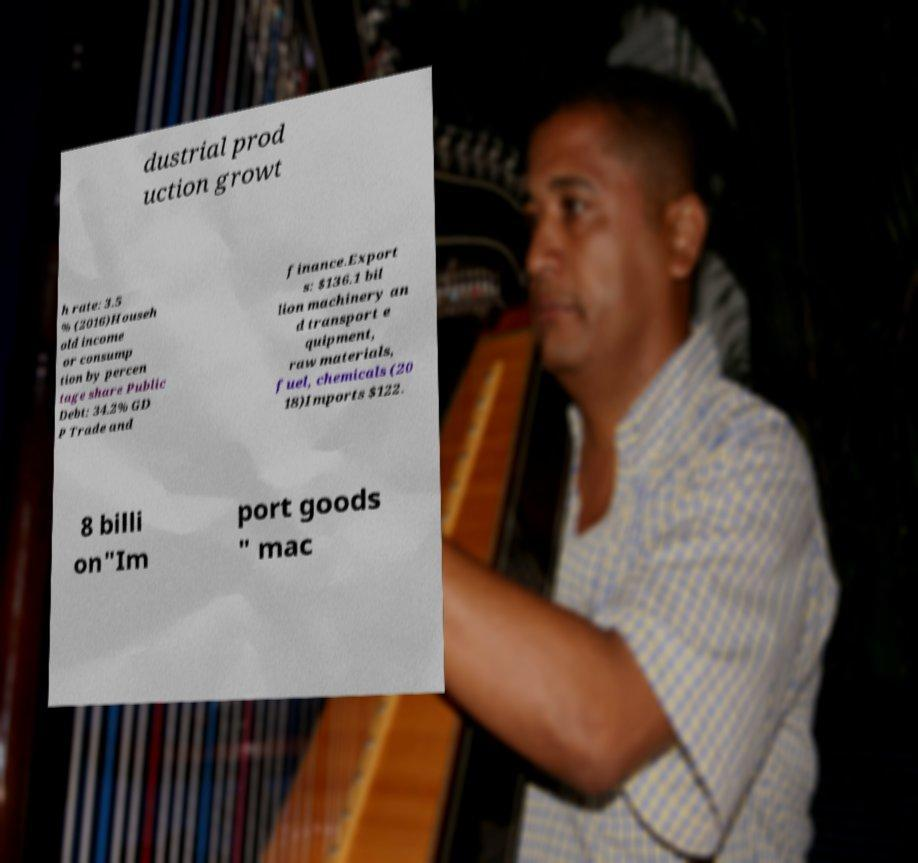I need the written content from this picture converted into text. Can you do that? dustrial prod uction growt h rate: 3.5 % (2016)Househ old income or consump tion by percen tage share Public Debt: 34.2% GD P Trade and finance.Export s: $136.1 bil lion machinery an d transport e quipment, raw materials, fuel, chemicals (20 18)Imports $122. 8 billi on"Im port goods " mac 